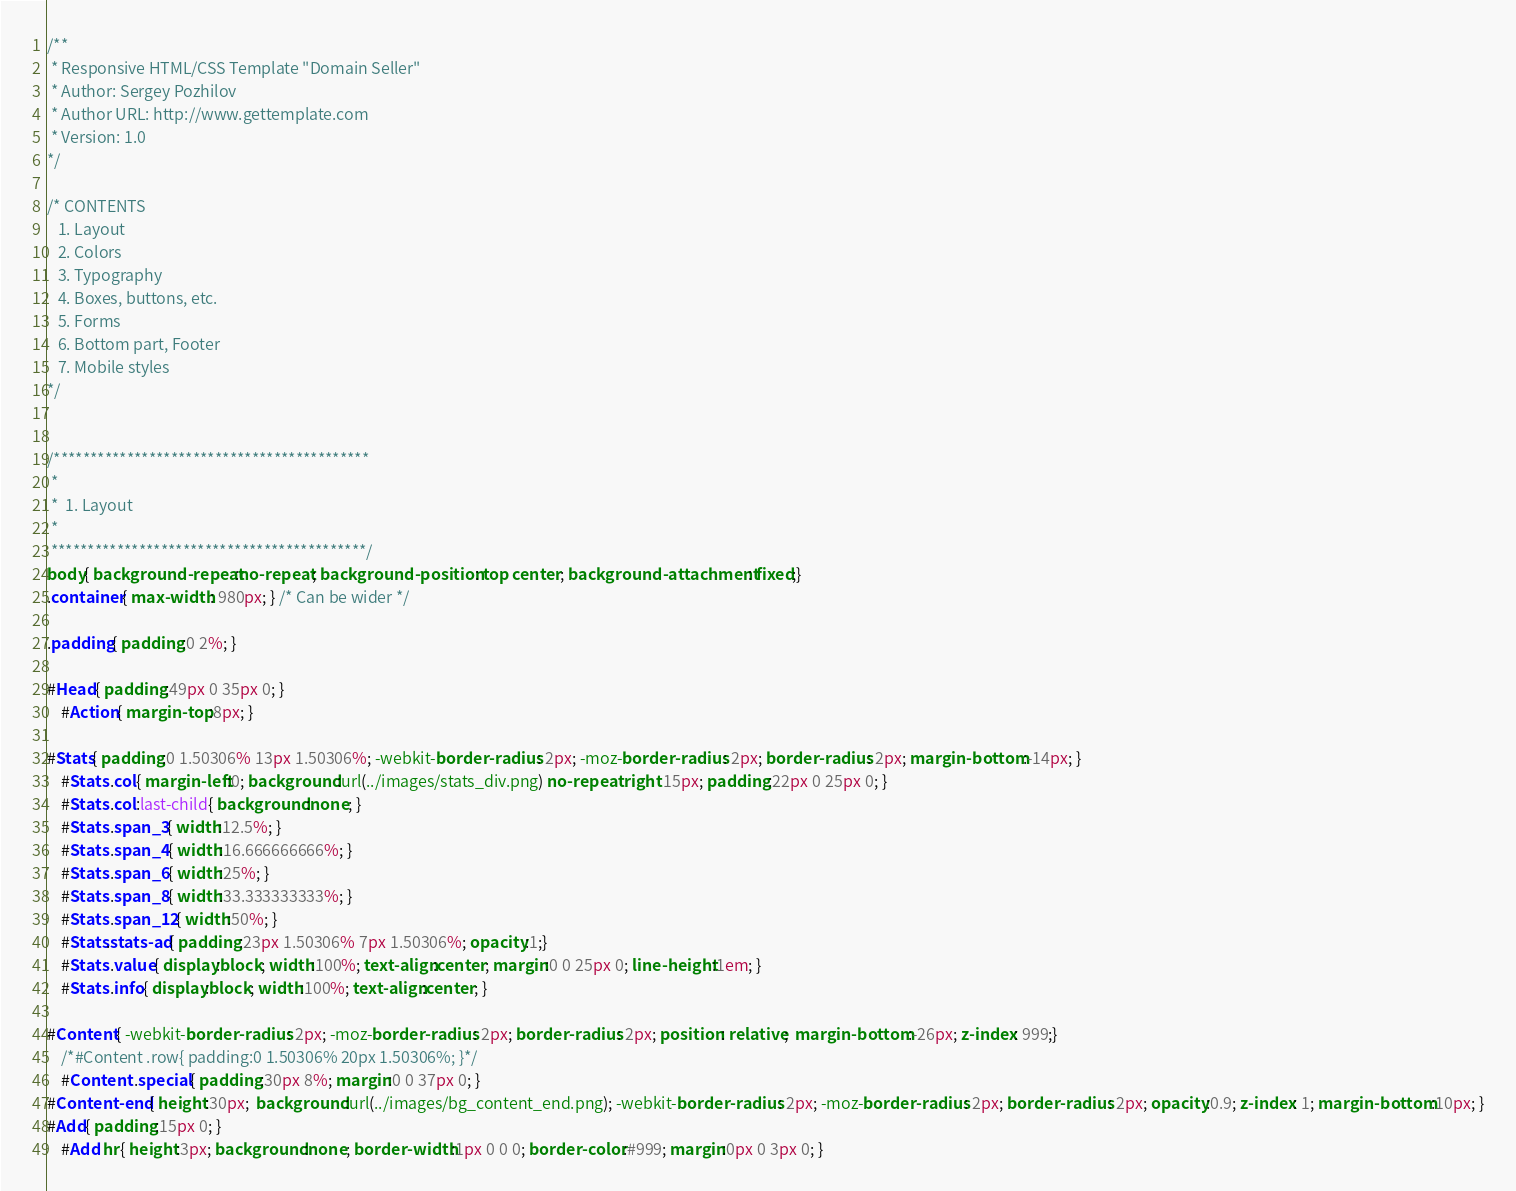Convert code to text. <code><loc_0><loc_0><loc_500><loc_500><_CSS_>/**
 * Responsive HTML/CSS Template "Domain Seller"
 * Author: Sergey Pozhilov
 * Author URL: http://www.gettemplate.com
 * Version: 1.0
*/

/* CONTENTS
   1. Layout
   2. Colors
   3. Typography
   4. Boxes, buttons, etc.
   5. Forms
   6. Bottom part, Footer
   7. Mobile styles
*/


/*******************************************
 *
 *  1. Layout
 *
 *******************************************/
body{ background-repeat:no-repeat; background-position: top center; background-attachment: fixed;}
.container{ max-width: 980px; } /* Can be wider */

.padding{ padding:0 2%; }

#Head{ padding:49px 0 35px 0; }
	#Action{ margin-top:8px; }

#Stats{ padding:0 1.50306% 13px 1.50306%; -webkit-border-radius: 2px; -moz-border-radius: 2px; border-radius: 2px; margin-bottom:-14px; }
	#Stats .col{ margin-left:0; background:url(../images/stats_div.png) no-repeat right 15px; padding:22px 0 25px 0; }
	#Stats .col:last-child{ background:none; }
	#Stats .span_3{ width:12.5%; }
	#Stats .span_4{ width:16.666666666%; }
	#Stats .span_6{ width:25%; }
	#Stats .span_8{ width:33.333333333%; }
	#Stats .span_12{ width:50%; }
	#Stats.stats-ad{ padding:23px 1.50306% 7px 1.50306%; opacity:1;}
	#Stats .value{ display:block; width:100%; text-align:center; margin:0 0 25px 0; line-height:1em; }
	#Stats .info{ display:block; width:100%; text-align:center; }

#Content{ -webkit-border-radius: 2px; -moz-border-radius: 2px; border-radius: 2px; position: relative;  margin-bottom:-26px; z-index: 999;}
	/*#Content .row{ padding:0 1.50306% 20px 1.50306%; }*/
	#Content .special{ padding:30px 8%; margin:0 0 37px 0; }	
#Content-end{ height:30px;  background:url(../images/bg_content_end.png); -webkit-border-radius: 2px; -moz-border-radius: 2px; border-radius: 2px; opacity:0.9; z-index: 1; margin-bottom:10px; }
#Add{ padding:15px 0; }
	#Add hr{ height:3px; background:none; border-width:1px 0 0 0; border-color:#999; margin:0px 0 3px 0; }</code> 